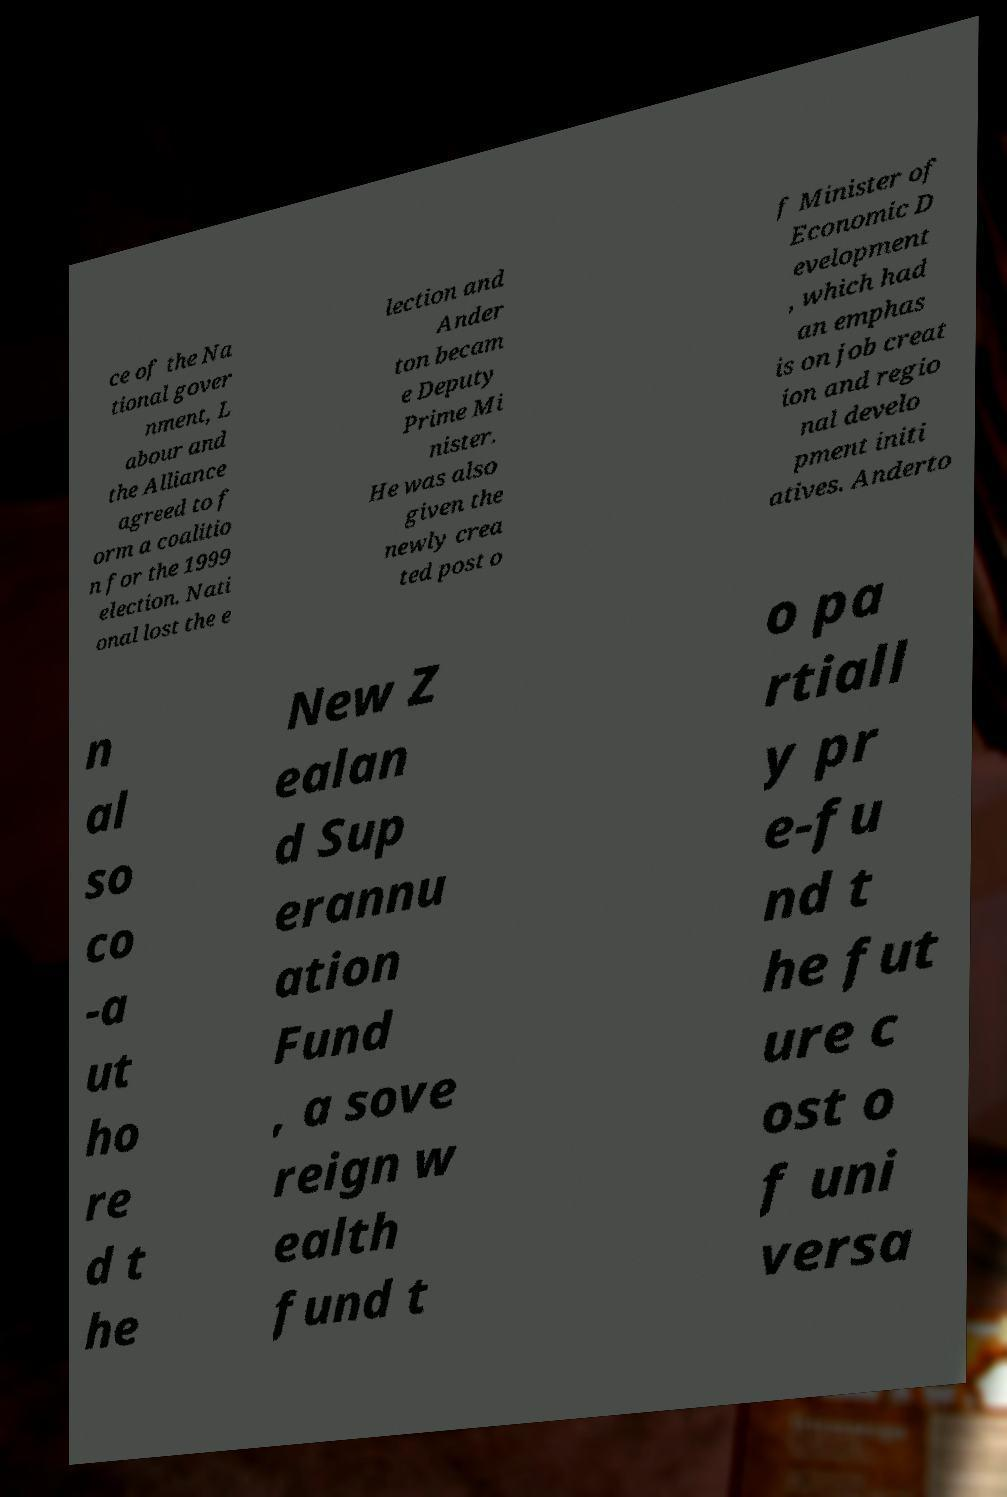There's text embedded in this image that I need extracted. Can you transcribe it verbatim? ce of the Na tional gover nment, L abour and the Alliance agreed to f orm a coalitio n for the 1999 election. Nati onal lost the e lection and Ander ton becam e Deputy Prime Mi nister. He was also given the newly crea ted post o f Minister of Economic D evelopment , which had an emphas is on job creat ion and regio nal develo pment initi atives. Anderto n al so co -a ut ho re d t he New Z ealan d Sup erannu ation Fund , a sove reign w ealth fund t o pa rtiall y pr e-fu nd t he fut ure c ost o f uni versa 